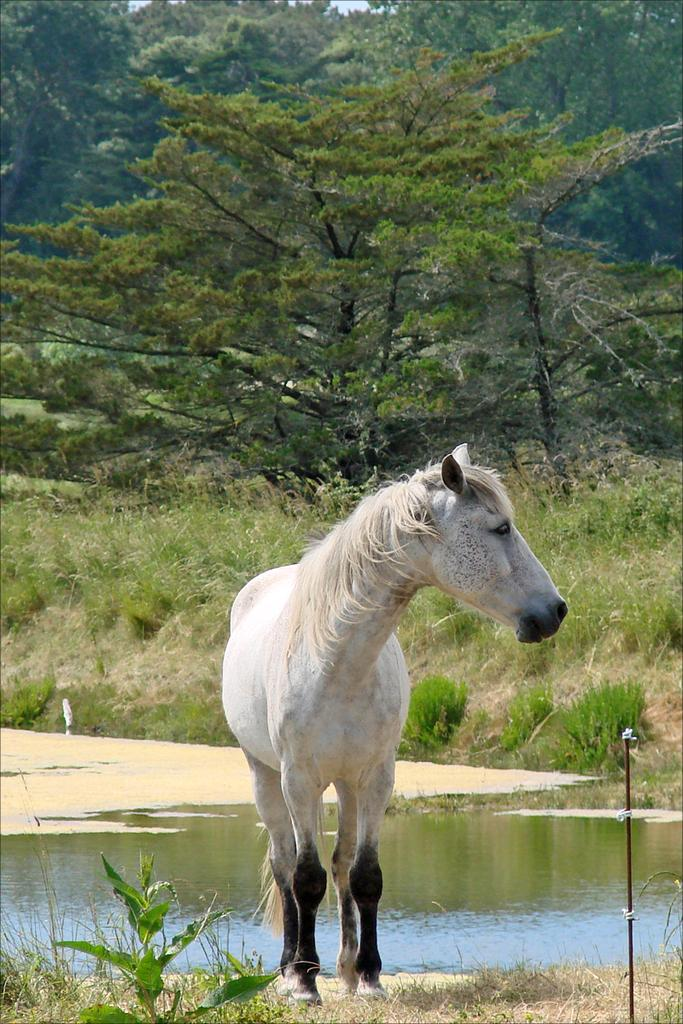What animal is present in the image? There is a horse in the image. What can be seen in the background of the image? There are trees in the background of the image. What is visible at the bottom of the image? Water is visible at the bottom of the image. What type of vegetation covers the ground in the image? The ground is covered with grass. How do the mice in the image express their anger towards the horse? There are no mice present in the image, and therefore no expression of anger can be observed. 